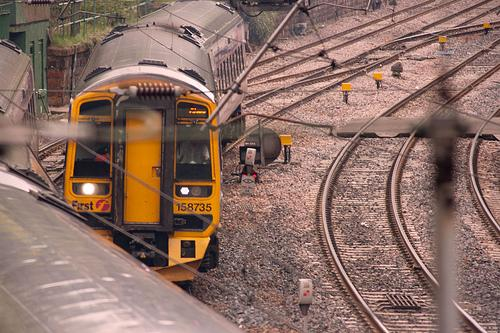Describe the general setting of the image regarding the railway station. The railway station has a metal-rodded track, electric cables, indicator lights, a green metal hut, and crushed stones alongside. Mention the train's position relative to the railway station and the nearby elements. The train is parked within the railway station, next to a green hut and surrounded by poles, stones, and tracks. Explain the scene in the image regarding the train and its surroundings. The yellow train is halted at the station, surrounded by poles and stones on the ground, with electric cables and a green hut near the tracks. Mention the most prominent element in the image and its color. The main subject in the picture is a yellow train parked at a railway station. In a concise manner, summarize the most evident features shown in the image. A yellow train is parked in the station, featuring headlights, a windshield, and metal tracks with crushed stones nearby. Focus on the materials and colors in the train and the surrounding area. In the image, there is a yellow train with black numbers, metal tracks, electric cables, and a green metal hut on a rocky ground. Share a quick overview of the entire scenario portrayed in the image. The image shows a stationary yellow train in a railway station, featuring various parts and surrounded by tracks, stones, and a green hut. Write a simple description of the scene and main subject in the image. A yellow train is stopped at a station with metal tracks and a green hut. Write an overall description of the train and its features visible in the image. The yellow train has a windshield with wipers, headlights, side windows, and black numbers, all parked at a railway station. Provide a brief description of the primary object and its appearance in the image. A yellow train with a windshield and front headlights is parked at a railway station, on a track with arranged rocks nearby. 